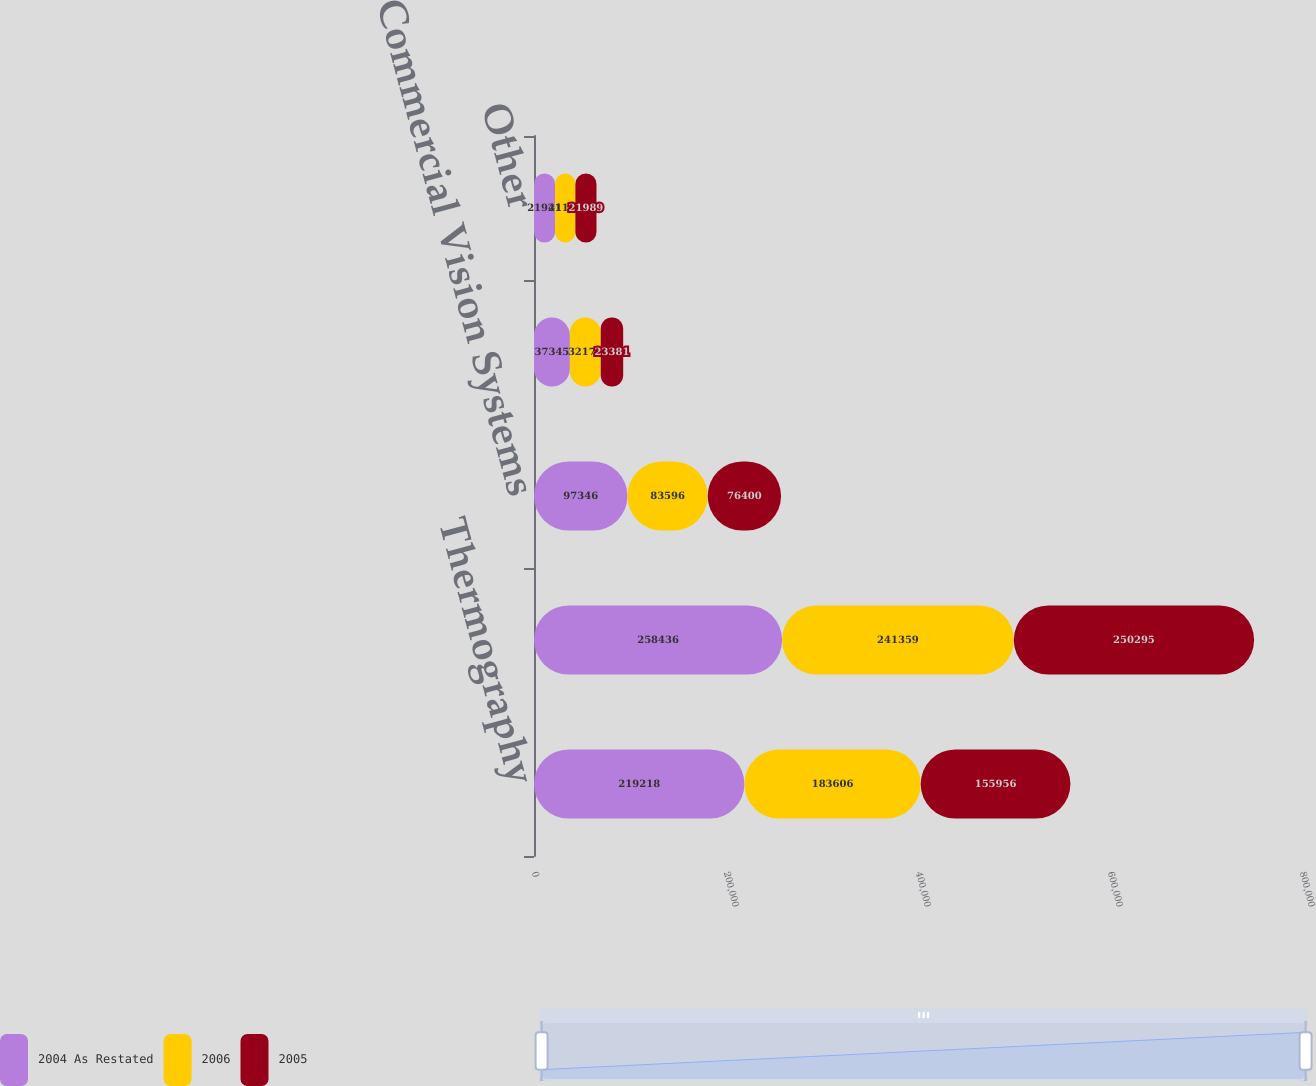Convert chart. <chart><loc_0><loc_0><loc_500><loc_500><stacked_bar_chart><ecel><fcel>Thermography<fcel>Government Systems<fcel>Commercial Vision Systems<fcel>Eliminations<fcel>Other<nl><fcel>2004 As Restated<fcel>219218<fcel>258436<fcel>97346<fcel>37345<fcel>21941<nl><fcel>2006<fcel>183606<fcel>241359<fcel>83596<fcel>32178<fcel>21158<nl><fcel>2005<fcel>155956<fcel>250295<fcel>76400<fcel>23381<fcel>21989<nl></chart> 